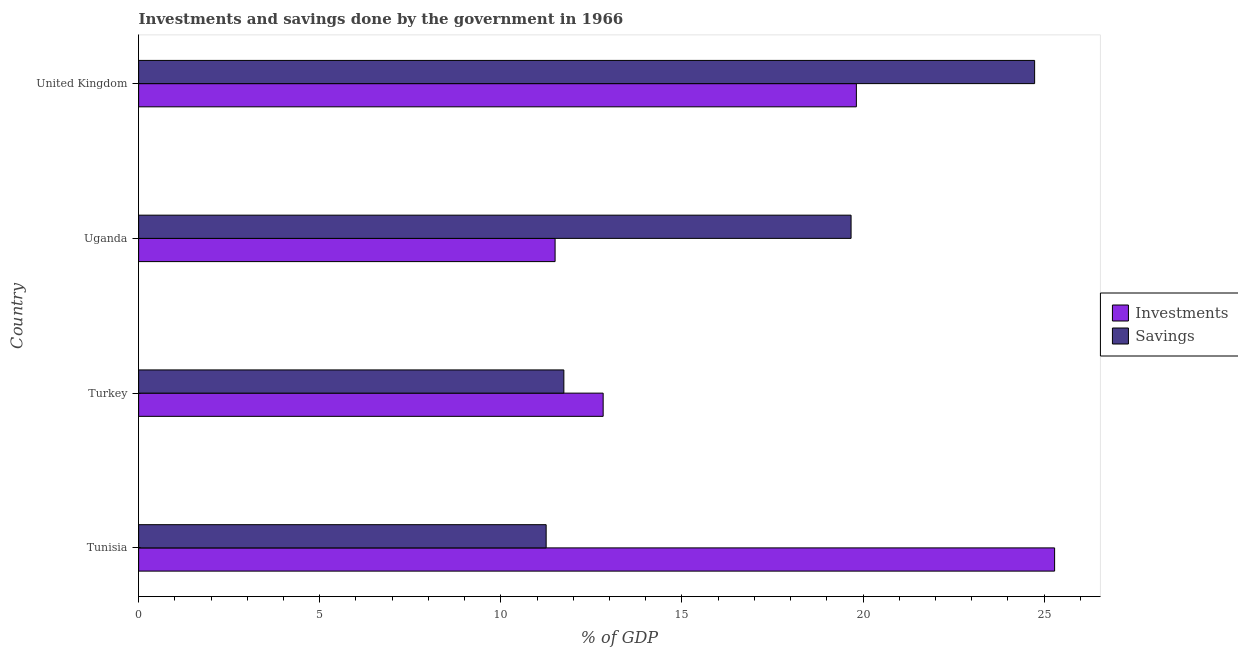What is the label of the 3rd group of bars from the top?
Offer a very short reply. Turkey. What is the savings of government in Uganda?
Your response must be concise. 19.67. Across all countries, what is the maximum investments of government?
Offer a very short reply. 25.29. Across all countries, what is the minimum savings of government?
Your response must be concise. 11.25. In which country was the investments of government maximum?
Offer a terse response. Tunisia. In which country was the savings of government minimum?
Offer a very short reply. Tunisia. What is the total investments of government in the graph?
Your answer should be compact. 69.43. What is the difference between the savings of government in Tunisia and that in Turkey?
Your answer should be compact. -0.49. What is the difference between the investments of government in United Kingdom and the savings of government in Uganda?
Provide a short and direct response. 0.15. What is the average savings of government per country?
Make the answer very short. 16.85. What is the difference between the savings of government and investments of government in Turkey?
Provide a short and direct response. -1.08. In how many countries, is the savings of government greater than 25 %?
Ensure brevity in your answer.  0. What is the ratio of the investments of government in Tunisia to that in Turkey?
Give a very brief answer. 1.97. Is the savings of government in Tunisia less than that in Turkey?
Keep it short and to the point. Yes. Is the difference between the investments of government in Turkey and United Kingdom greater than the difference between the savings of government in Turkey and United Kingdom?
Your answer should be very brief. Yes. What is the difference between the highest and the second highest savings of government?
Your answer should be compact. 5.07. What is the difference between the highest and the lowest savings of government?
Offer a very short reply. 13.49. In how many countries, is the savings of government greater than the average savings of government taken over all countries?
Your response must be concise. 2. What does the 2nd bar from the top in Tunisia represents?
Your answer should be very brief. Investments. What does the 2nd bar from the bottom in Turkey represents?
Your answer should be compact. Savings. Are all the bars in the graph horizontal?
Offer a terse response. Yes. How many countries are there in the graph?
Offer a very short reply. 4. What is the difference between two consecutive major ticks on the X-axis?
Your answer should be very brief. 5. Does the graph contain any zero values?
Keep it short and to the point. No. Where does the legend appear in the graph?
Offer a terse response. Center right. How are the legend labels stacked?
Offer a very short reply. Vertical. What is the title of the graph?
Offer a very short reply. Investments and savings done by the government in 1966. Does "Nonresident" appear as one of the legend labels in the graph?
Give a very brief answer. No. What is the label or title of the X-axis?
Provide a short and direct response. % of GDP. What is the % of GDP of Investments in Tunisia?
Your response must be concise. 25.29. What is the % of GDP in Savings in Tunisia?
Your response must be concise. 11.25. What is the % of GDP of Investments in Turkey?
Your answer should be compact. 12.82. What is the % of GDP of Savings in Turkey?
Keep it short and to the point. 11.74. What is the % of GDP of Investments in Uganda?
Make the answer very short. 11.5. What is the % of GDP in Savings in Uganda?
Keep it short and to the point. 19.67. What is the % of GDP in Investments in United Kingdom?
Provide a short and direct response. 19.82. What is the % of GDP of Savings in United Kingdom?
Keep it short and to the point. 24.74. Across all countries, what is the maximum % of GDP of Investments?
Provide a succinct answer. 25.29. Across all countries, what is the maximum % of GDP in Savings?
Ensure brevity in your answer.  24.74. Across all countries, what is the minimum % of GDP of Investments?
Ensure brevity in your answer.  11.5. Across all countries, what is the minimum % of GDP of Savings?
Keep it short and to the point. 11.25. What is the total % of GDP in Investments in the graph?
Keep it short and to the point. 69.43. What is the total % of GDP of Savings in the graph?
Offer a terse response. 67.4. What is the difference between the % of GDP of Investments in Tunisia and that in Turkey?
Ensure brevity in your answer.  12.46. What is the difference between the % of GDP of Savings in Tunisia and that in Turkey?
Your response must be concise. -0.49. What is the difference between the % of GDP of Investments in Tunisia and that in Uganda?
Your answer should be compact. 13.79. What is the difference between the % of GDP in Savings in Tunisia and that in Uganda?
Ensure brevity in your answer.  -8.42. What is the difference between the % of GDP in Investments in Tunisia and that in United Kingdom?
Offer a very short reply. 5.47. What is the difference between the % of GDP in Savings in Tunisia and that in United Kingdom?
Your answer should be compact. -13.49. What is the difference between the % of GDP of Investments in Turkey and that in Uganda?
Ensure brevity in your answer.  1.33. What is the difference between the % of GDP of Savings in Turkey and that in Uganda?
Your answer should be very brief. -7.93. What is the difference between the % of GDP of Investments in Turkey and that in United Kingdom?
Your response must be concise. -6.99. What is the difference between the % of GDP in Savings in Turkey and that in United Kingdom?
Ensure brevity in your answer.  -13. What is the difference between the % of GDP in Investments in Uganda and that in United Kingdom?
Make the answer very short. -8.32. What is the difference between the % of GDP of Savings in Uganda and that in United Kingdom?
Your answer should be very brief. -5.07. What is the difference between the % of GDP in Investments in Tunisia and the % of GDP in Savings in Turkey?
Your answer should be compact. 13.55. What is the difference between the % of GDP in Investments in Tunisia and the % of GDP in Savings in Uganda?
Ensure brevity in your answer.  5.62. What is the difference between the % of GDP of Investments in Tunisia and the % of GDP of Savings in United Kingdom?
Make the answer very short. 0.55. What is the difference between the % of GDP of Investments in Turkey and the % of GDP of Savings in Uganda?
Keep it short and to the point. -6.84. What is the difference between the % of GDP of Investments in Turkey and the % of GDP of Savings in United Kingdom?
Your answer should be very brief. -11.91. What is the difference between the % of GDP of Investments in Uganda and the % of GDP of Savings in United Kingdom?
Offer a terse response. -13.24. What is the average % of GDP of Investments per country?
Give a very brief answer. 17.36. What is the average % of GDP of Savings per country?
Provide a short and direct response. 16.85. What is the difference between the % of GDP in Investments and % of GDP in Savings in Tunisia?
Offer a very short reply. 14.04. What is the difference between the % of GDP of Investments and % of GDP of Savings in Turkey?
Provide a succinct answer. 1.08. What is the difference between the % of GDP of Investments and % of GDP of Savings in Uganda?
Give a very brief answer. -8.17. What is the difference between the % of GDP in Investments and % of GDP in Savings in United Kingdom?
Your response must be concise. -4.92. What is the ratio of the % of GDP of Investments in Tunisia to that in Turkey?
Your response must be concise. 1.97. What is the ratio of the % of GDP in Savings in Tunisia to that in Turkey?
Keep it short and to the point. 0.96. What is the ratio of the % of GDP of Investments in Tunisia to that in Uganda?
Your answer should be very brief. 2.2. What is the ratio of the % of GDP of Savings in Tunisia to that in Uganda?
Keep it short and to the point. 0.57. What is the ratio of the % of GDP in Investments in Tunisia to that in United Kingdom?
Make the answer very short. 1.28. What is the ratio of the % of GDP in Savings in Tunisia to that in United Kingdom?
Offer a terse response. 0.45. What is the ratio of the % of GDP in Investments in Turkey to that in Uganda?
Your answer should be very brief. 1.12. What is the ratio of the % of GDP of Savings in Turkey to that in Uganda?
Your answer should be very brief. 0.6. What is the ratio of the % of GDP in Investments in Turkey to that in United Kingdom?
Ensure brevity in your answer.  0.65. What is the ratio of the % of GDP in Savings in Turkey to that in United Kingdom?
Provide a succinct answer. 0.47. What is the ratio of the % of GDP of Investments in Uganda to that in United Kingdom?
Ensure brevity in your answer.  0.58. What is the ratio of the % of GDP in Savings in Uganda to that in United Kingdom?
Ensure brevity in your answer.  0.8. What is the difference between the highest and the second highest % of GDP of Investments?
Offer a terse response. 5.47. What is the difference between the highest and the second highest % of GDP in Savings?
Keep it short and to the point. 5.07. What is the difference between the highest and the lowest % of GDP in Investments?
Make the answer very short. 13.79. What is the difference between the highest and the lowest % of GDP in Savings?
Give a very brief answer. 13.49. 